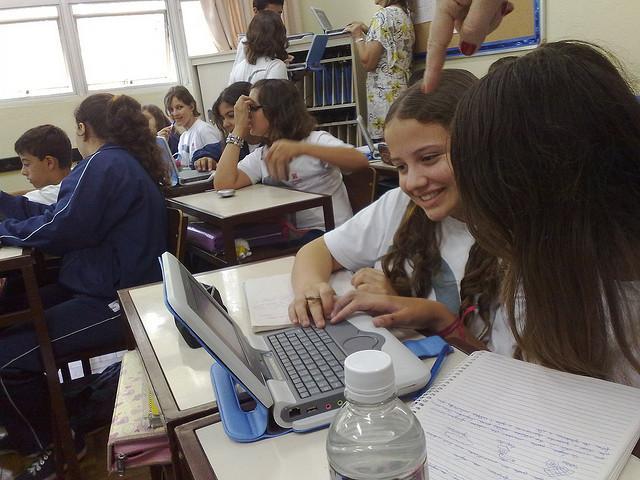Who is probably pointing above the students? teacher 